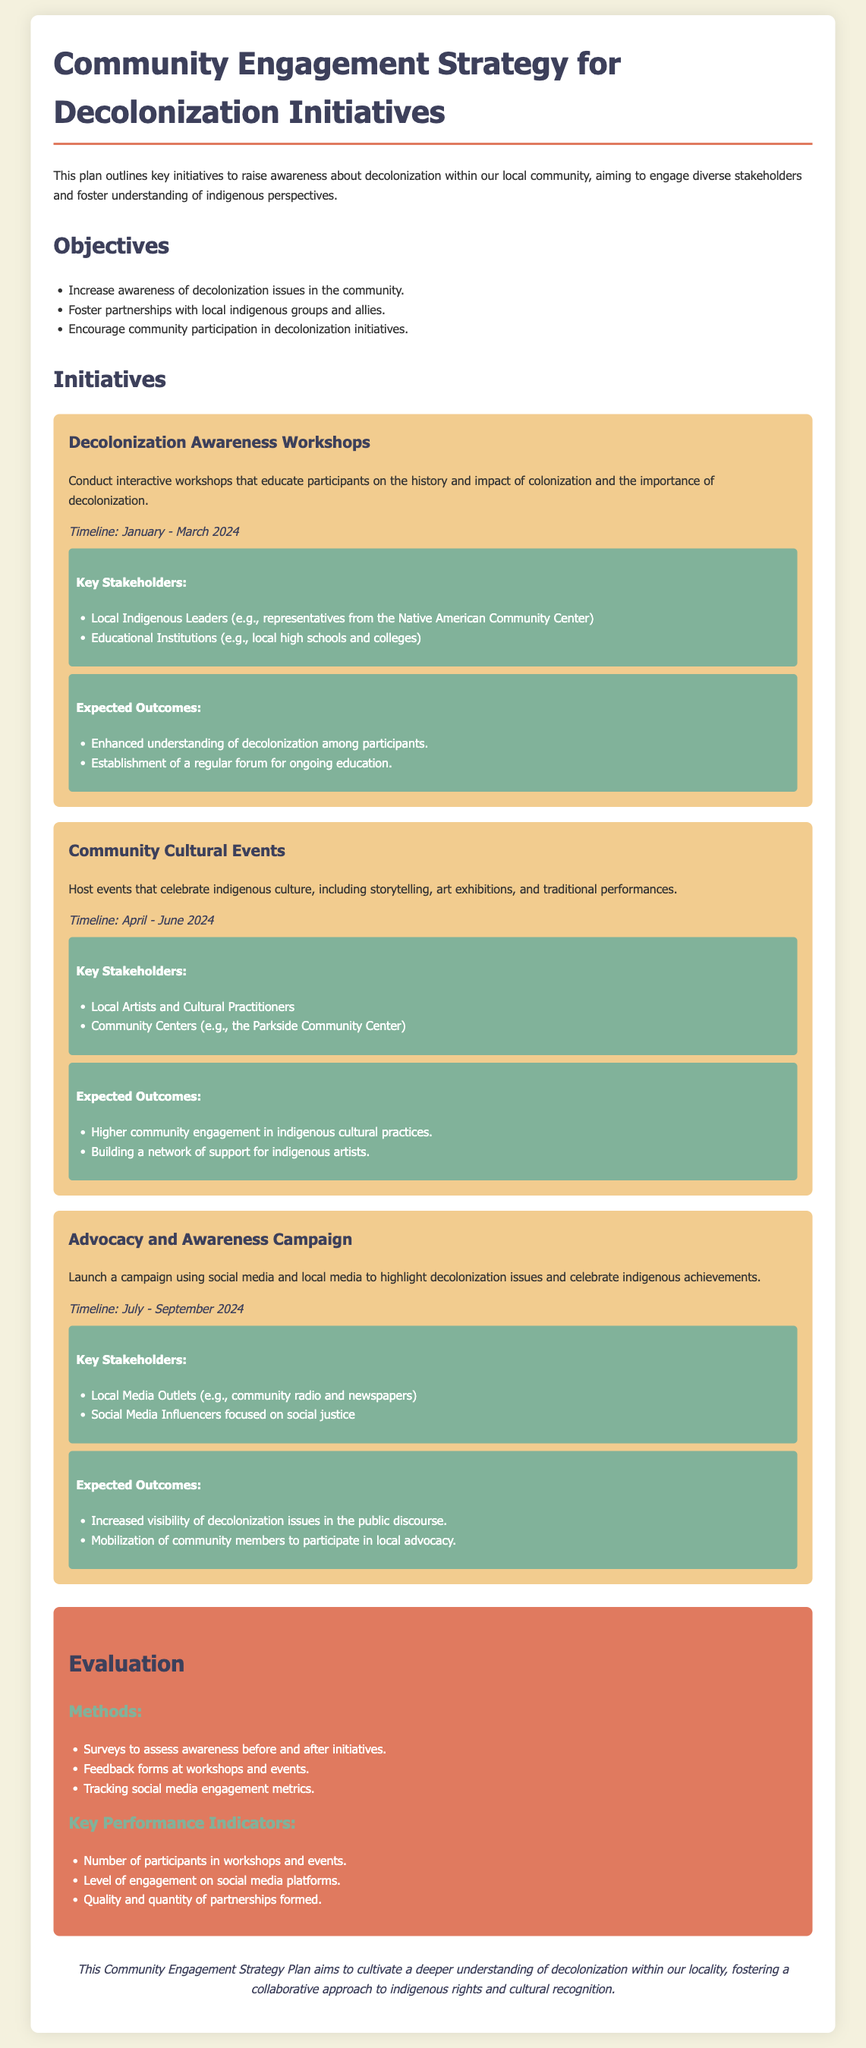what is the main objective of this plan? The main objective is to raise awareness about decolonization within the local community.
Answer: raise awareness about decolonization how long is the first initiative scheduled to last? The first initiative, Decolonization Awareness Workshops, has a timeline from January to March 2024.
Answer: three months who is one of the key stakeholders involved in the community cultural events? In the community cultural events, one of the key stakeholders mentioned is the Parkside Community Center.
Answer: Parkside Community Center what is one expected outcome of the advocacy and awareness campaign? The expected outcome of the advocacy campaign is increased visibility of decolonization issues in public discourse.
Answer: increased visibility of decolonization issues what method will be used to evaluate the initiatives? Surveys will be used to assess awareness before and after initiatives.
Answer: Surveys how many initiatives are outlined in the document? There are three initiatives outlined in the document.
Answer: three what color is used for the evaluation section background? The background color for the evaluation section is specified as e07a5f.
Answer: e07a5f which stakeholders are associated with the Decolonization Awareness Workshops? The key stakeholders associated with the workshops include local indigenous leaders and educational institutions.
Answer: local indigenous leaders, educational institutions 